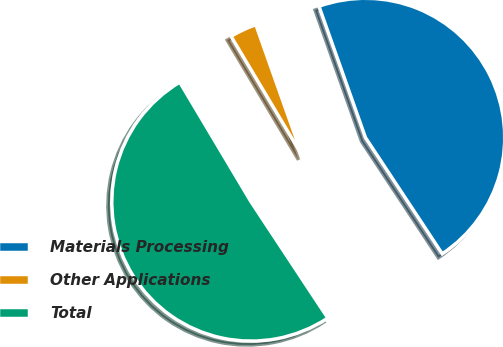Convert chart. <chart><loc_0><loc_0><loc_500><loc_500><pie_chart><fcel>Materials Processing<fcel>Other Applications<fcel>Total<nl><fcel>46.13%<fcel>3.14%<fcel>50.74%<nl></chart> 